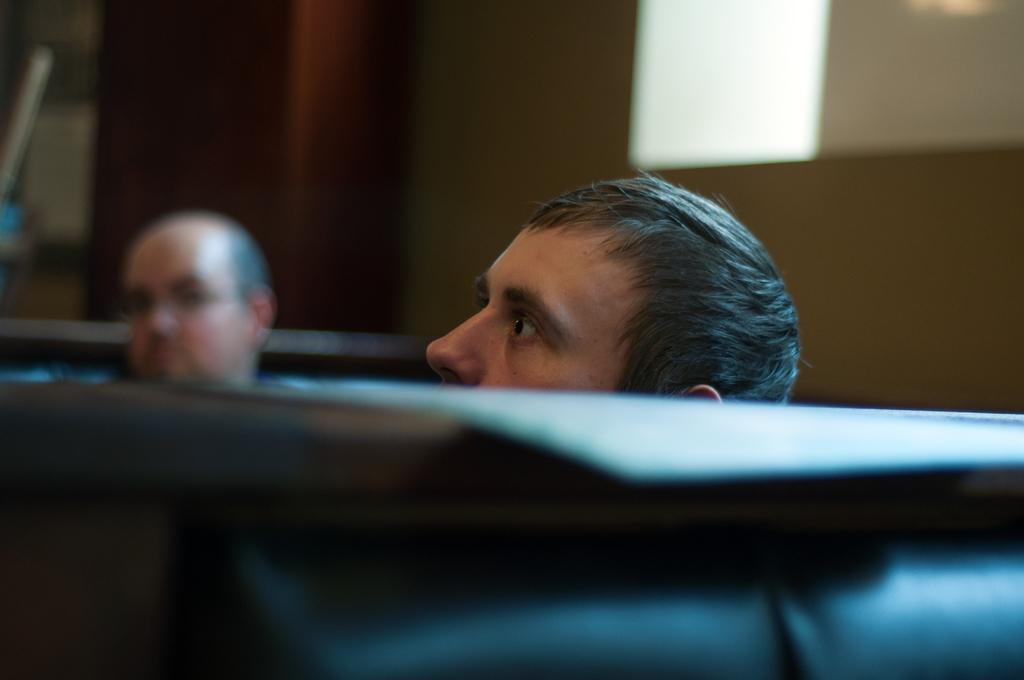How many people are in the center of the image? There are two persons in the center of the image. What else can be seen in the center of the image besides the people? There are other objects in the center of the image. Can you describe any objects visible in the background of the image? There are other objects visible in the background of the image. What type of straw is being used by the bear in the image? There is no bear present in the image, and therefore no straw being used by a bear. 